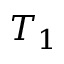<formula> <loc_0><loc_0><loc_500><loc_500>T _ { 1 }</formula> 